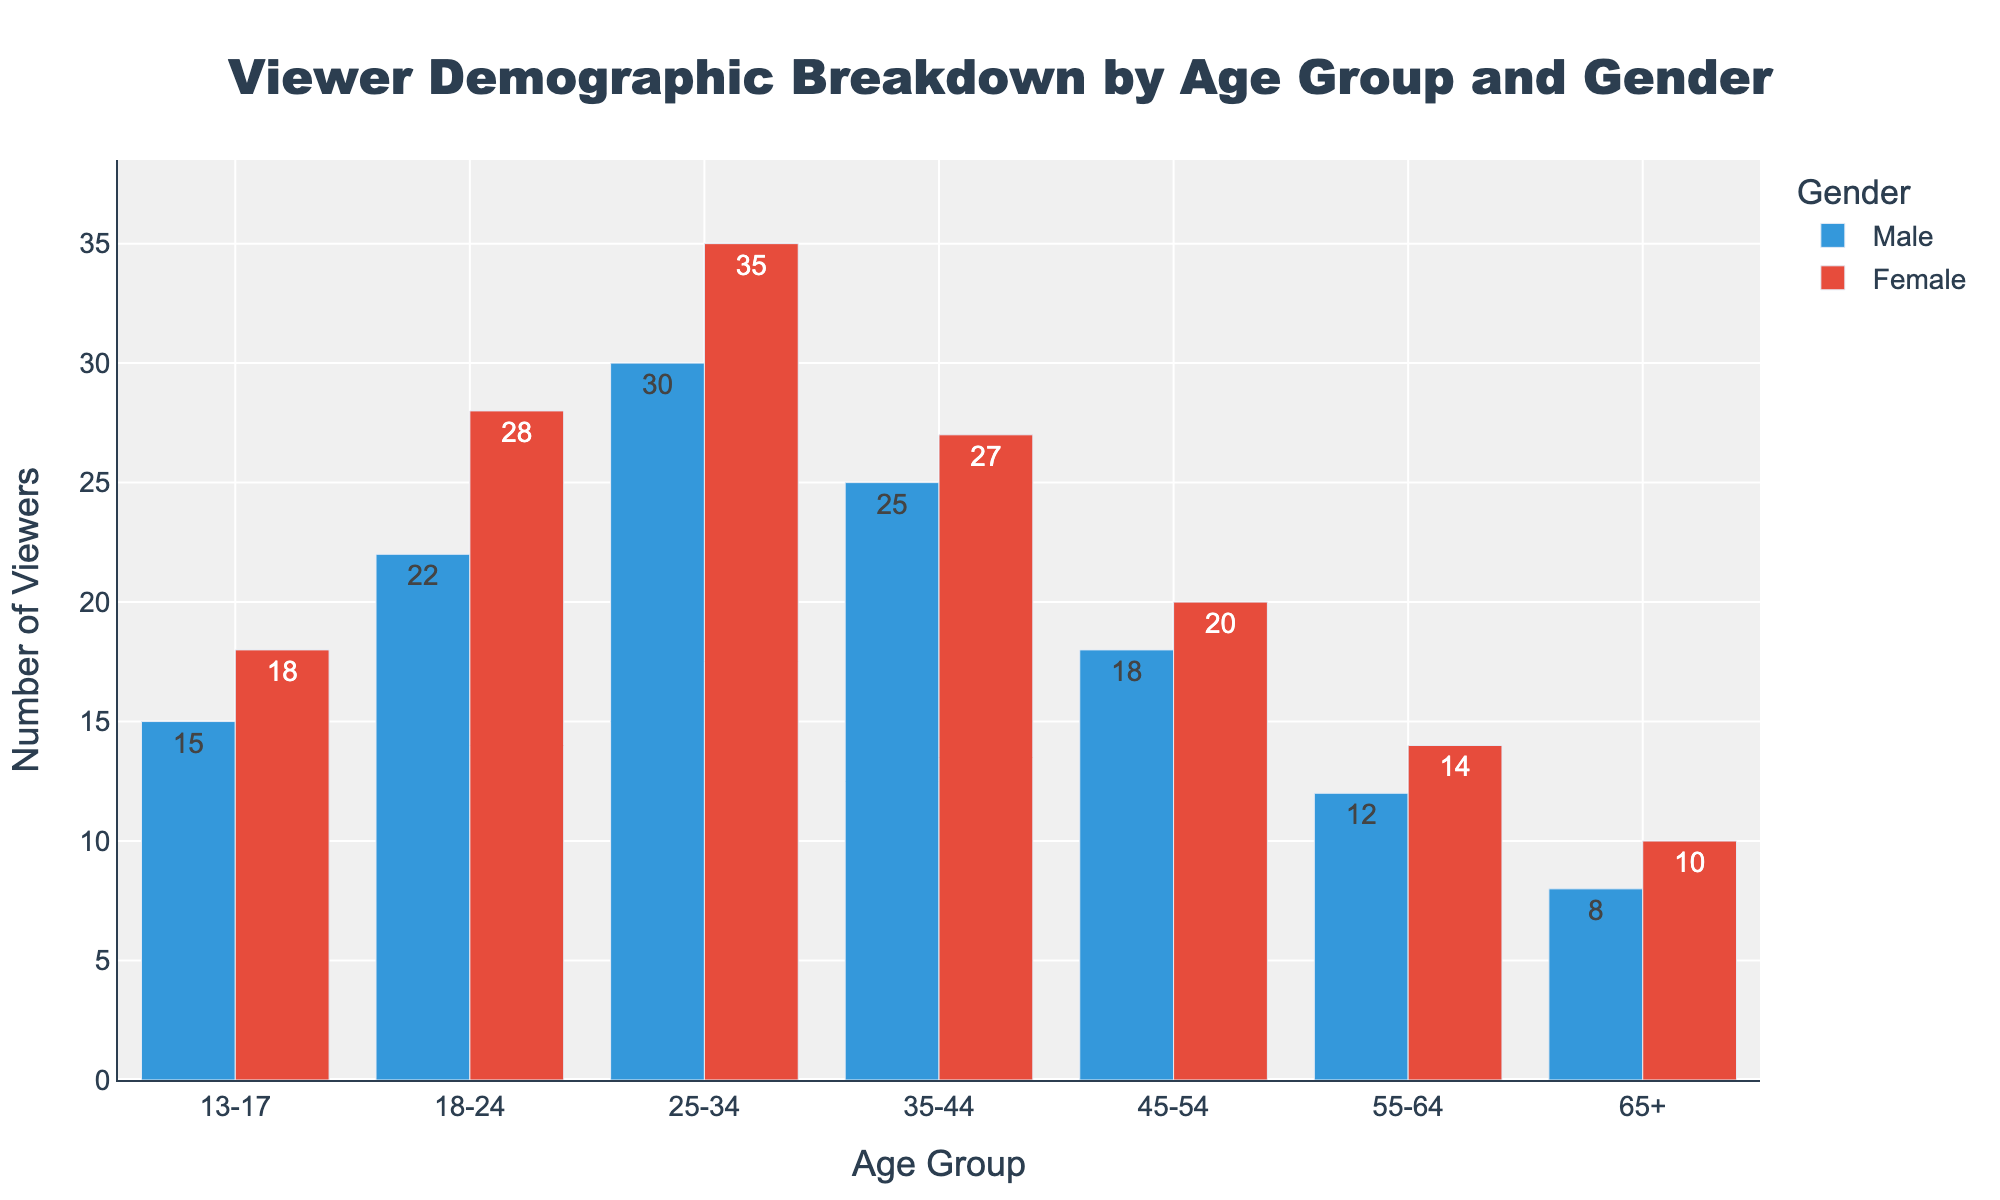What is the total number of viewers in the 18-24 age group? Add the number of male viewers in the 18-24 age group (22) and the number of female viewers (28). The total is 22 + 28 = 50.
Answer: 50 Which age group has the highest number of female viewers? Compare the number of female viewers across the different age groups. The 25-34 age group has the highest with 35 female viewers.
Answer: 25-34 In the 35-44 age group, which gender has fewer viewers and by how much? Compare the number of male viewers (25) to female viewers (27) in the 35-44 age group. Males have fewer viewers. The difference is 27 - 25 = 2.
Answer: Male, 2 What is the average number of male viewers across all age groups? Sum the number of male viewers across all age groups (15 + 22 + 30 + 25 + 18 + 12 + 8) = 130. There are 7 age groups, so the average is 130 / 7 ≈ 18.57.
Answer: ~18.57 How many more viewers are there in the 13-17 age group compared to the 65+ age group? Calculate the total number of viewers in the 13-17 age group (15 male + 18 female = 33) and in the 65+ age group (8 male + 10 female = 18). The difference is 33 - 18 = 15.
Answer: 15 Which gender has the highest number of viewers in the 25-34 age group and by how much? Compare the number of male viewers (30) to female viewers (35) in the 25-34 age group. Females have more viewers with a difference of 35 - 30 = 5.
Answer: Female, 5 Are there more male viewers in the 45-54 age group or in the 55-64 age group? Compare the number of male viewers in the 45-54 age group (18) and in the 55-64 age group (12). There are more male viewers in the 45-54 age group.
Answer: 45-54 What is the difference in the total number of viewers between the 18-24 and 55-64 age groups? Calculate the total viewers in the 18-24 age group (22 male + 28 female = 50) and in the 55-64 age group (12 male + 14 female = 26). The difference is 50 - 26 = 24.
Answer: 24 How does the number of male viewers in the 65+ age group compare to the number of female viewers in the 13-17 age group? Compare the number of male viewers in the 65+ age group (8) to the number of female viewers in the 13-17 age group (18). There are fewer male viewers in the 65+ age group.
Answer: Fewer Which age group has the least overall number of viewers? Calculate the total viewers for each age group, and identify the age group with the lowest number. The age group 65+ has the least with (8 male + 10 female = 18) viewers.
Answer: 65+ 